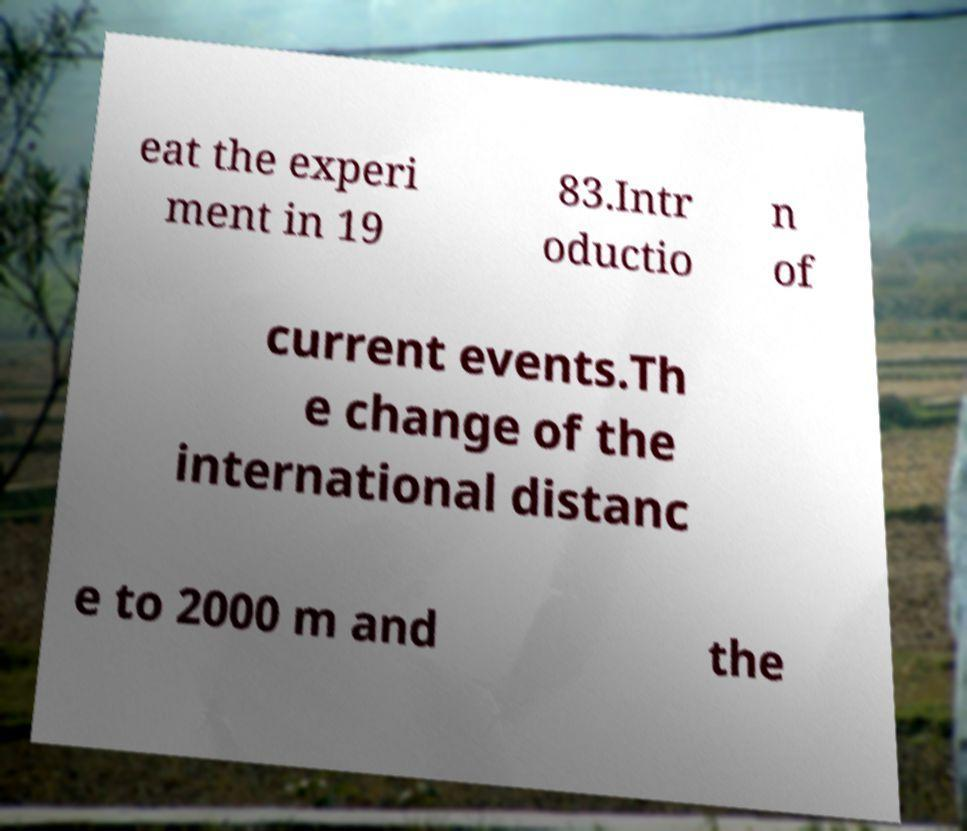Can you accurately transcribe the text from the provided image for me? eat the experi ment in 19 83.Intr oductio n of current events.Th e change of the international distanc e to 2000 m and the 